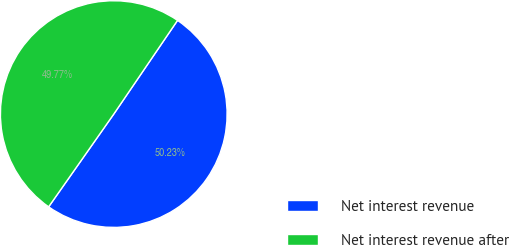<chart> <loc_0><loc_0><loc_500><loc_500><pie_chart><fcel>Net interest revenue<fcel>Net interest revenue after<nl><fcel>50.23%<fcel>49.77%<nl></chart> 